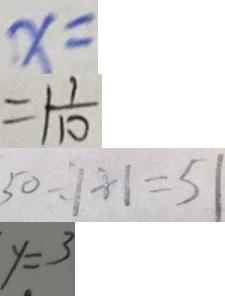<formula> <loc_0><loc_0><loc_500><loc_500>x = 
 = 1 \frac { 1 } { 1 0 } 
 5 0 \div 1 + 1 = 5 1 
 y = 3</formula> 